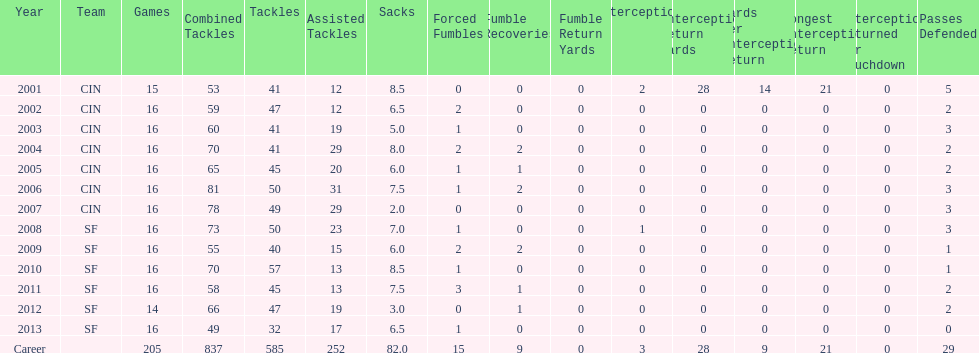Write the full table. {'header': ['Year', 'Team', 'Games', 'Combined Tackles', 'Tackles', 'Assisted Tackles', 'Sacks', 'Forced Fumbles', 'Fumble Recoveries', 'Fumble Return Yards', 'Interceptions', 'Interception Return Yards', 'Yards per Interception Return', 'Longest Interception Return', 'Interceptions Returned for Touchdown', 'Passes Defended'], 'rows': [['2001', 'CIN', '15', '53', '41', '12', '8.5', '0', '0', '0', '2', '28', '14', '21', '0', '5'], ['2002', 'CIN', '16', '59', '47', '12', '6.5', '2', '0', '0', '0', '0', '0', '0', '0', '2'], ['2003', 'CIN', '16', '60', '41', '19', '5.0', '1', '0', '0', '0', '0', '0', '0', '0', '3'], ['2004', 'CIN', '16', '70', '41', '29', '8.0', '2', '2', '0', '0', '0', '0', '0', '0', '2'], ['2005', 'CIN', '16', '65', '45', '20', '6.0', '1', '1', '0', '0', '0', '0', '0', '0', '2'], ['2006', 'CIN', '16', '81', '50', '31', '7.5', '1', '2', '0', '0', '0', '0', '0', '0', '3'], ['2007', 'CIN', '16', '78', '49', '29', '2.0', '0', '0', '0', '0', '0', '0', '0', '0', '3'], ['2008', 'SF', '16', '73', '50', '23', '7.0', '1', '0', '0', '1', '0', '0', '0', '0', '3'], ['2009', 'SF', '16', '55', '40', '15', '6.0', '2', '2', '0', '0', '0', '0', '0', '0', '1'], ['2010', 'SF', '16', '70', '57', '13', '8.5', '1', '0', '0', '0', '0', '0', '0', '0', '1'], ['2011', 'SF', '16', '58', '45', '13', '7.5', '3', '1', '0', '0', '0', '0', '0', '0', '2'], ['2012', 'SF', '14', '66', '47', '19', '3.0', '0', '1', '0', '0', '0', '0', '0', '0', '2'], ['2013', 'SF', '16', '49', '32', '17', '6.5', '1', '0', '0', '0', '0', '0', '0', '0', '0'], ['Career', '', '205', '837', '585', '252', '82.0', '15', '9', '0', '3', '28', '9', '21', '0', '29']]} How many seasons had combined tackles of 70 or more? 5. 